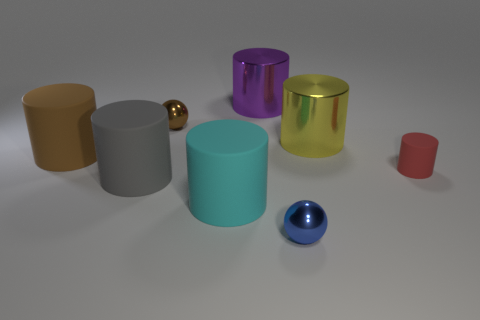There is a metal ball to the left of the cyan rubber thing; is it the same size as the metallic cylinder in front of the large purple cylinder?
Give a very brief answer. No. There is a brown thing that is the same material as the yellow thing; what is its size?
Ensure brevity in your answer.  Small. There is a cylinder that is behind the tiny cylinder and left of the cyan thing; what is it made of?
Give a very brief answer. Rubber. There is a cylinder that is left of the big gray matte cylinder; does it have the same color as the sphere that is behind the brown matte cylinder?
Make the answer very short. Yes. Do the large object that is on the right side of the blue object and the red cylinder have the same material?
Ensure brevity in your answer.  No. What is the color of the other tiny matte thing that is the same shape as the brown rubber thing?
Your response must be concise. Red. Are there any other things that have the same shape as the purple thing?
Your answer should be compact. Yes. Are there an equal number of big brown cylinders in front of the brown matte cylinder and big blue metallic blocks?
Keep it short and to the point. Yes. There is a blue ball; are there any spheres left of it?
Offer a very short reply. Yes. How big is the shiny cylinder that is on the right side of the small sphere that is to the right of the cylinder behind the large yellow cylinder?
Keep it short and to the point. Large. 